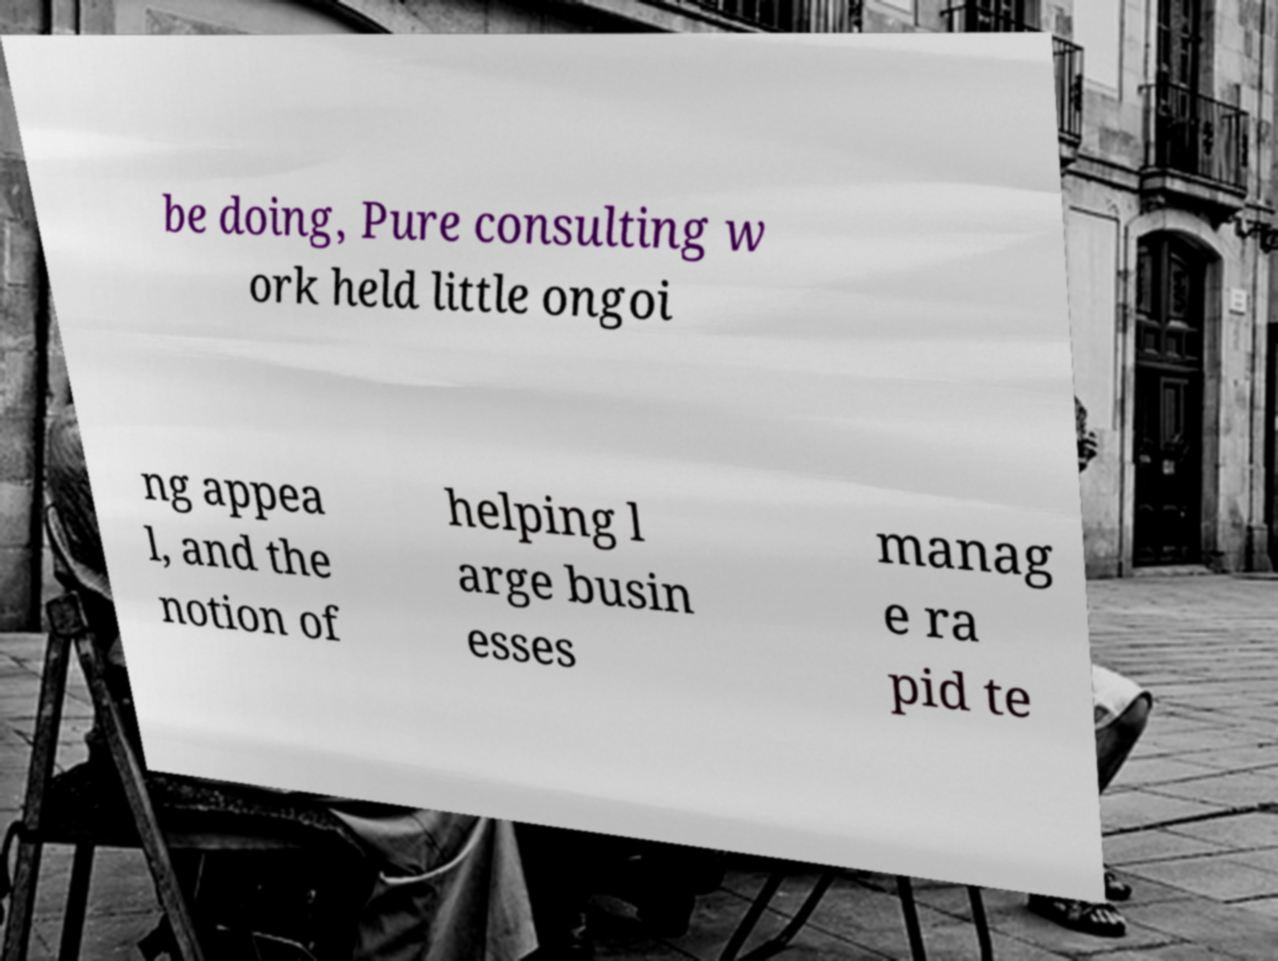Please read and relay the text visible in this image. What does it say? be doing, Pure consulting w ork held little ongoi ng appea l, and the notion of helping l arge busin esses manag e ra pid te 